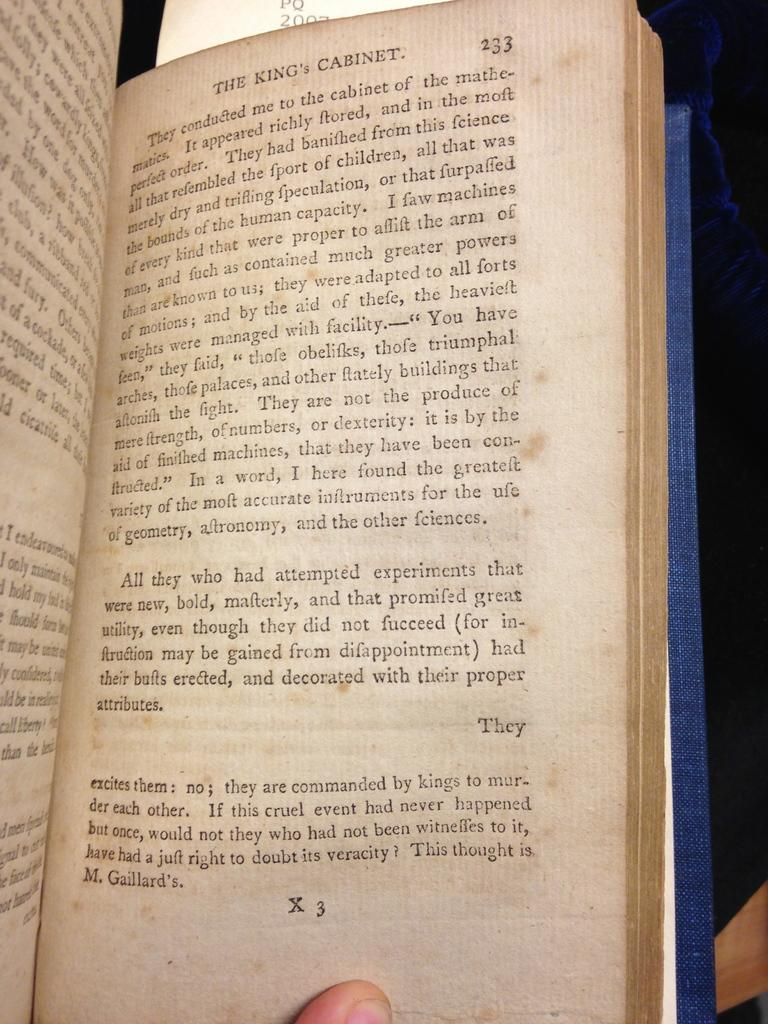What object is visible in the image that is related to reading or learning? There is a book in the image. Can you describe the state of the book in the image? The book is opened. What can be seen inside the book? There is script in the book. Who is interacting with the book in the image? A person is holding the book with their hand. What type of harbor can be seen in the image? There is no harbor present in the image; it features a book being held by a person. What discovery was made by the person holding the book in the image? The image does not provide information about any discoveries made by the person holding the book. 